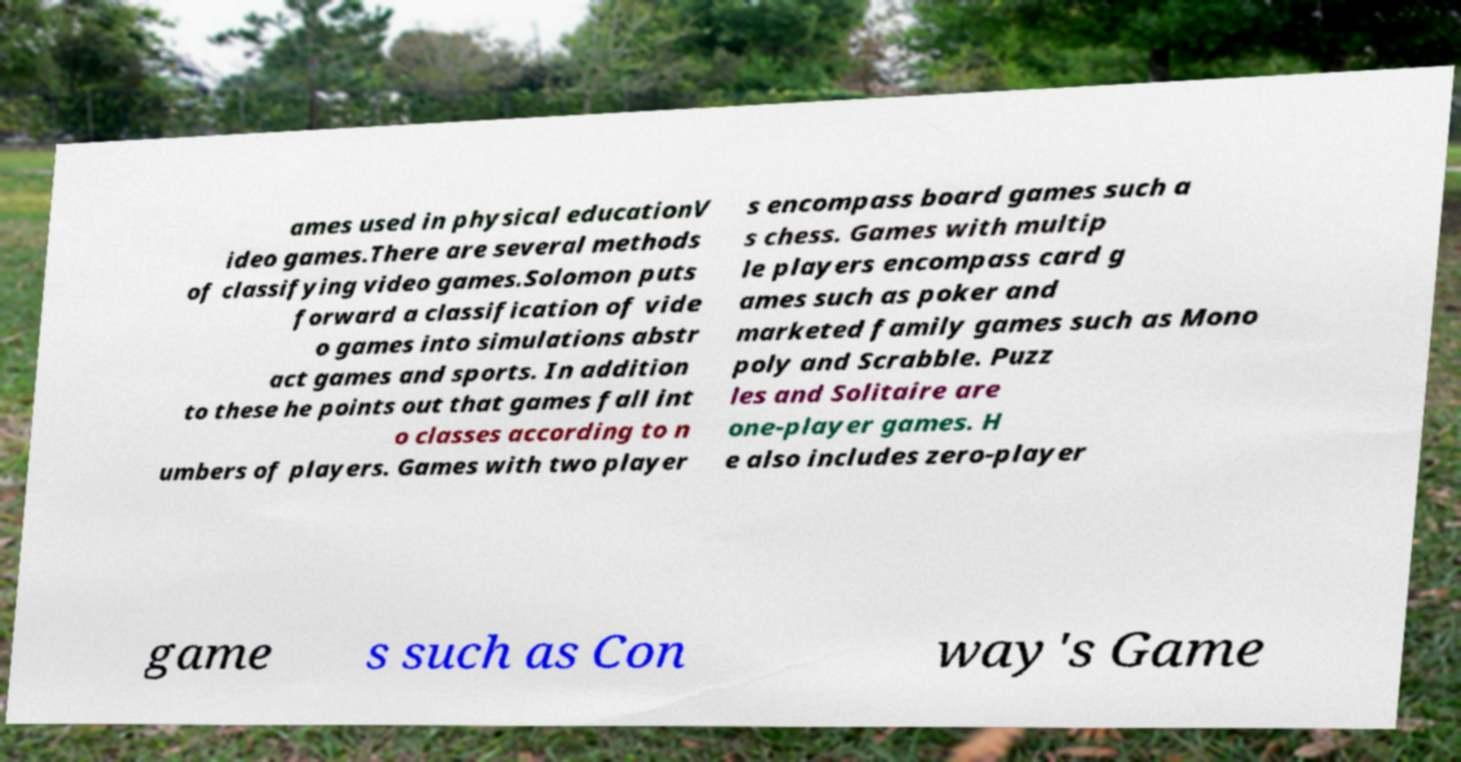Please identify and transcribe the text found in this image. ames used in physical educationV ideo games.There are several methods of classifying video games.Solomon puts forward a classification of vide o games into simulations abstr act games and sports. In addition to these he points out that games fall int o classes according to n umbers of players. Games with two player s encompass board games such a s chess. Games with multip le players encompass card g ames such as poker and marketed family games such as Mono poly and Scrabble. Puzz les and Solitaire are one-player games. H e also includes zero-player game s such as Con way's Game 